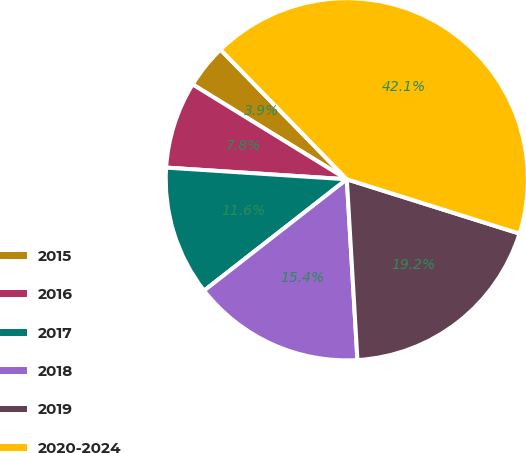<chart> <loc_0><loc_0><loc_500><loc_500><pie_chart><fcel>2015<fcel>2016<fcel>2017<fcel>2018<fcel>2019<fcel>2020-2024<nl><fcel>3.93%<fcel>7.75%<fcel>11.57%<fcel>15.39%<fcel>19.21%<fcel>42.14%<nl></chart> 